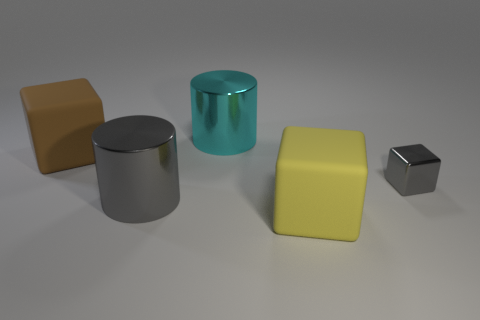There is a brown object that is the same shape as the big yellow object; what is its material?
Your answer should be very brief. Rubber. Is the material of the big gray cylinder the same as the large block that is behind the yellow thing?
Your response must be concise. No. There is a large object behind the big rubber cube to the left of the gray metal cylinder; what is its shape?
Provide a succinct answer. Cylinder. How many large things are either gray metallic cubes or red cylinders?
Your answer should be very brief. 0. How many big gray things are the same shape as the yellow rubber thing?
Ensure brevity in your answer.  0. Is the shape of the brown object the same as the matte thing that is on the right side of the cyan metal cylinder?
Provide a succinct answer. Yes. How many big matte cubes are left of the large cyan cylinder?
Provide a short and direct response. 1. Is there a blue matte sphere that has the same size as the brown matte thing?
Give a very brief answer. No. Do the gray metallic thing that is in front of the small thing and the cyan shiny object have the same shape?
Keep it short and to the point. Yes. The tiny metal object has what color?
Give a very brief answer. Gray. 